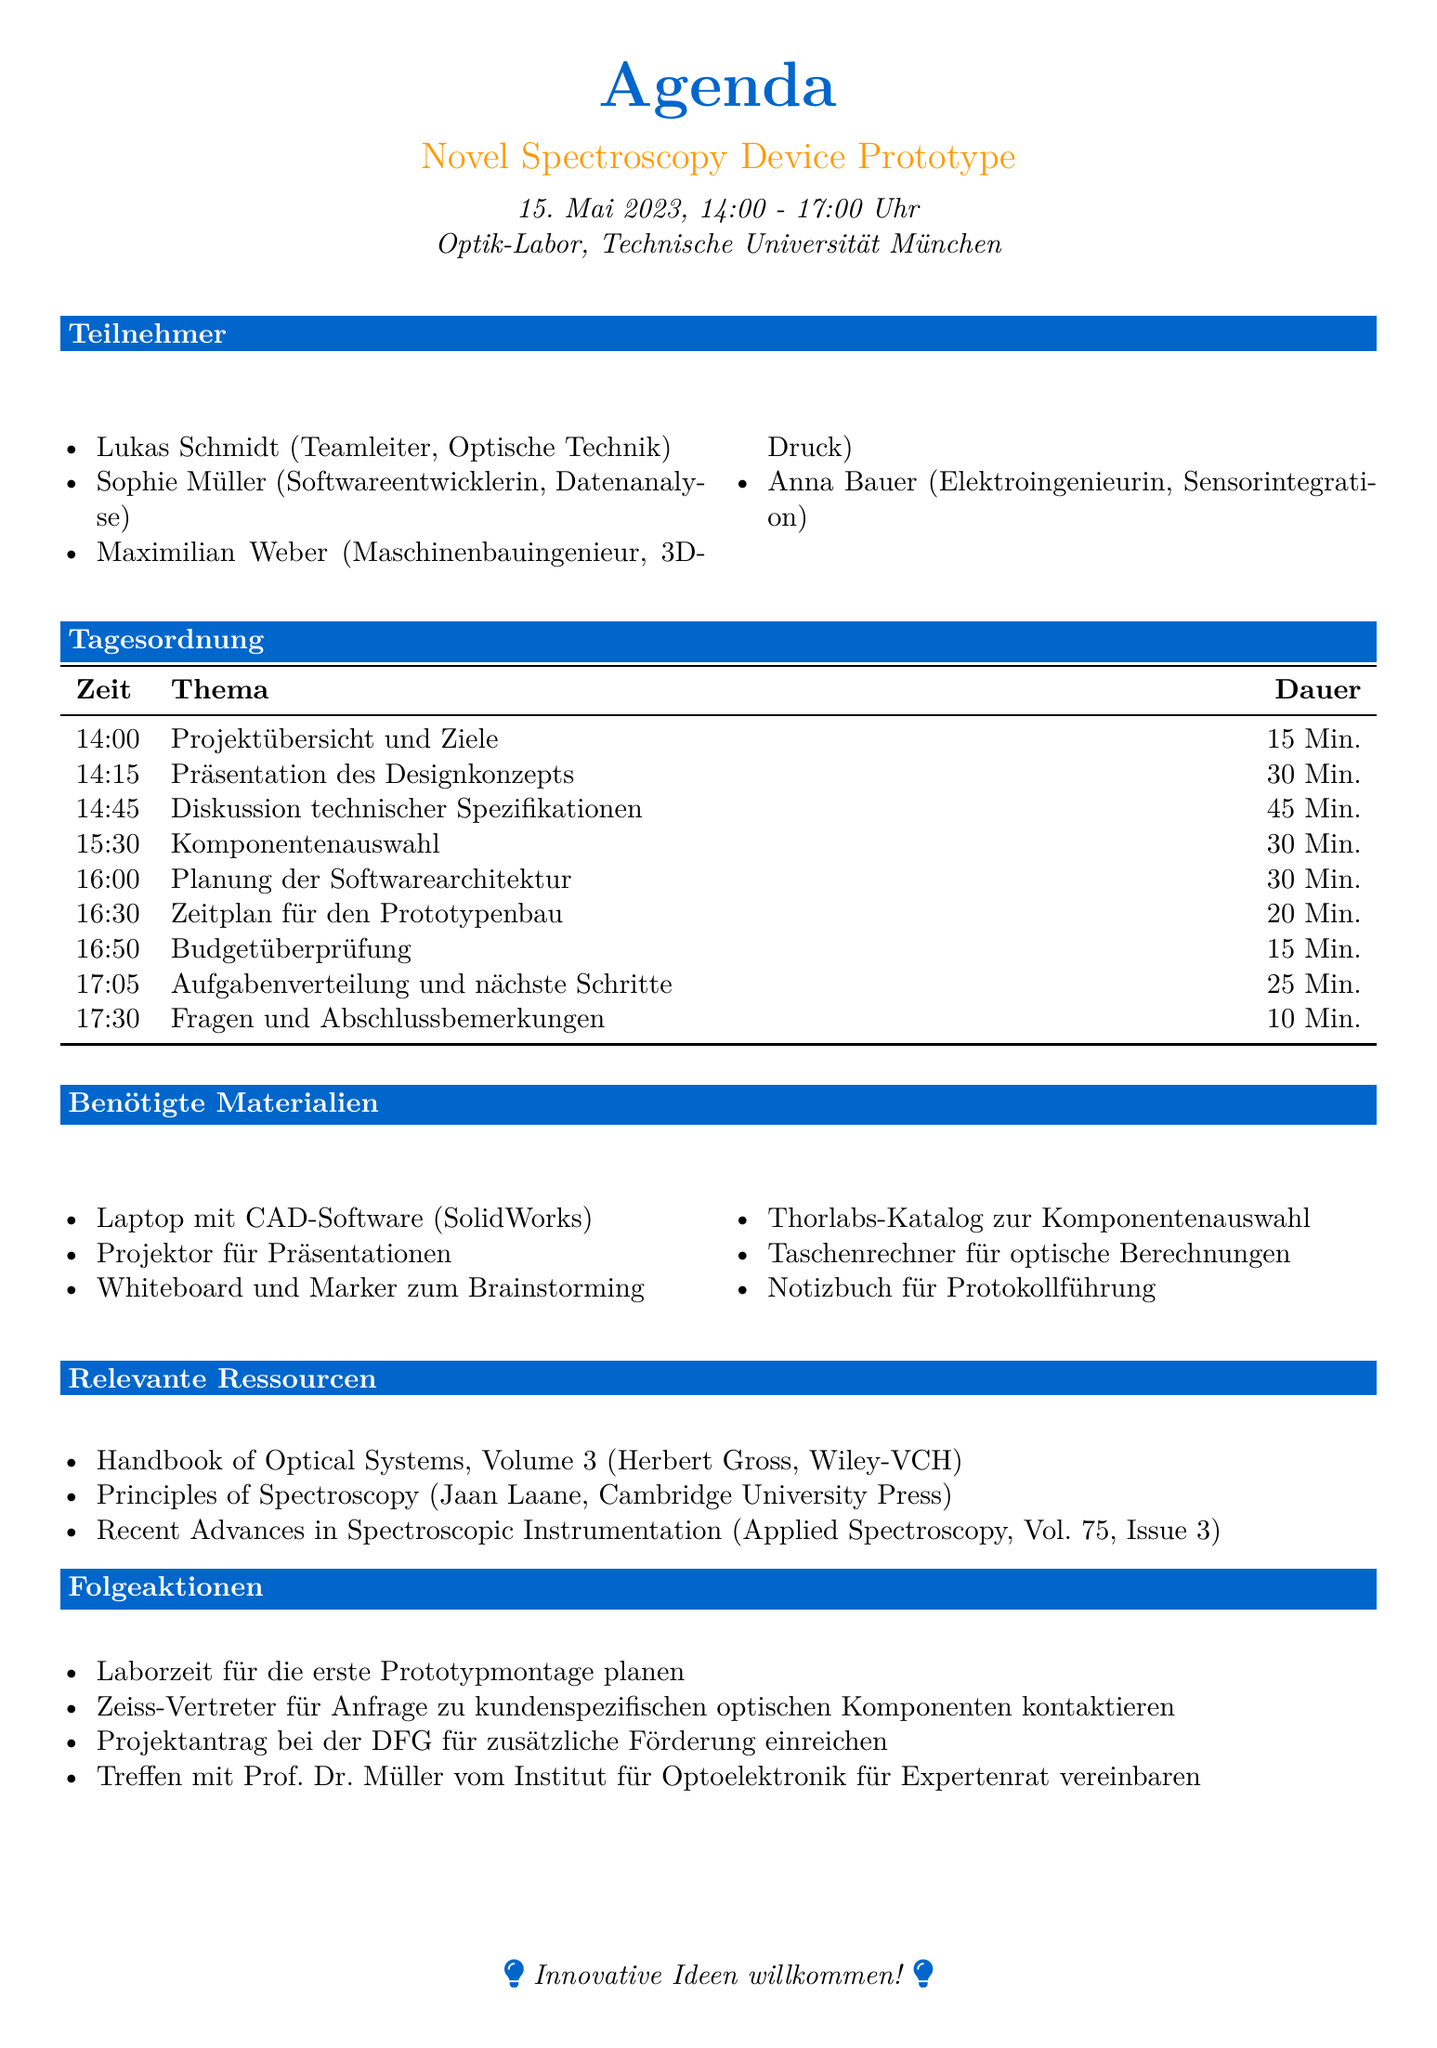What is the project name? The project name is mentioned at the beginning of the agenda document.
Answer: Novel Spectroscopy Device Prototype What date is the meeting scheduled for? The meeting date is listed under the meeting details.
Answer: 15. Mai 2023 Who is the Team Leader? The role and name of the Team Leader are provided in the team members section.
Answer: Lukas Schmidt How long is the discussion on technical specifications? The duration of each agenda item is included in the table of agenda items.
Answer: 45 Min What is one of the required materials for the meeting? The materials needed for the meeting are listed in the required materials section.
Answer: Laptop with CAD software (SolidWorks) Which component catalog will be used for selection? The document specifies which catalog to consult during component selection.
Answer: Thorlabs catalog What is one follow-up action mentioned in the document? The follow-up actions are detailed at the end of the agenda.
Answer: Schedule lab time for initial prototype assembly What will the team discuss during the first agenda item? The agenda specifies the topics for discussion in each item.
Answer: Project Overview and Goals How many team members are listed in the document? The number of team members is indicated in the team members section.
Answer: 4 